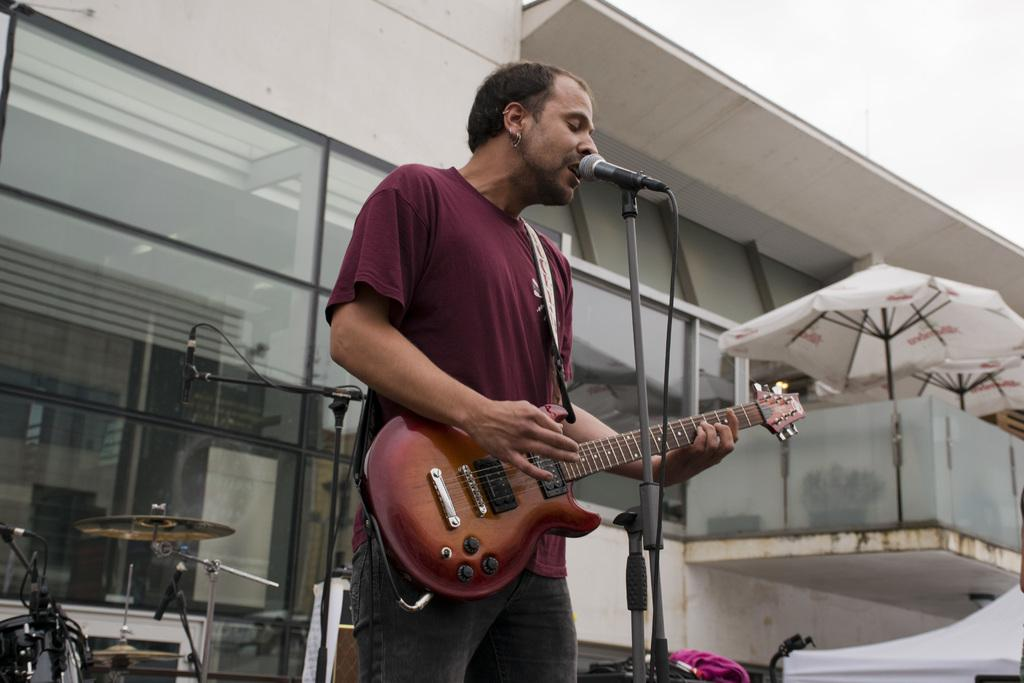What is the person in the image doing? The person is playing a guitar and singing. What object is the person using to amplify their voice? The person is in front of a microphone. What other musical instruments are present in the image? There are musical instruments behind the person. What type of scarf is the stranger wearing in the image? There is no stranger present in the image, and therefore no scarf can be observed. 